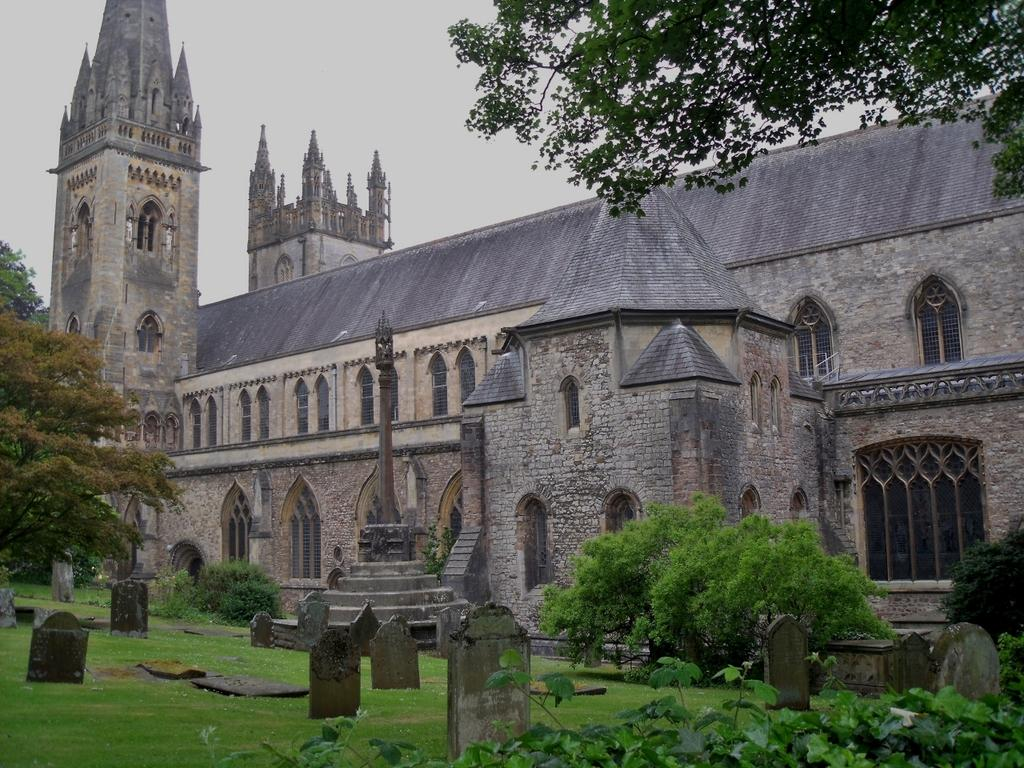What type of building is present in the image? There is a church in the image. What can be found at the bottom of the image? There are graves at the bottom of the image. What type of vegetation is visible in the image? There is grass in the image. Are there any other natural elements present in the image? Yes, there are trees in the image. What is the weight of the engine in the image? There is no engine present in the image. 